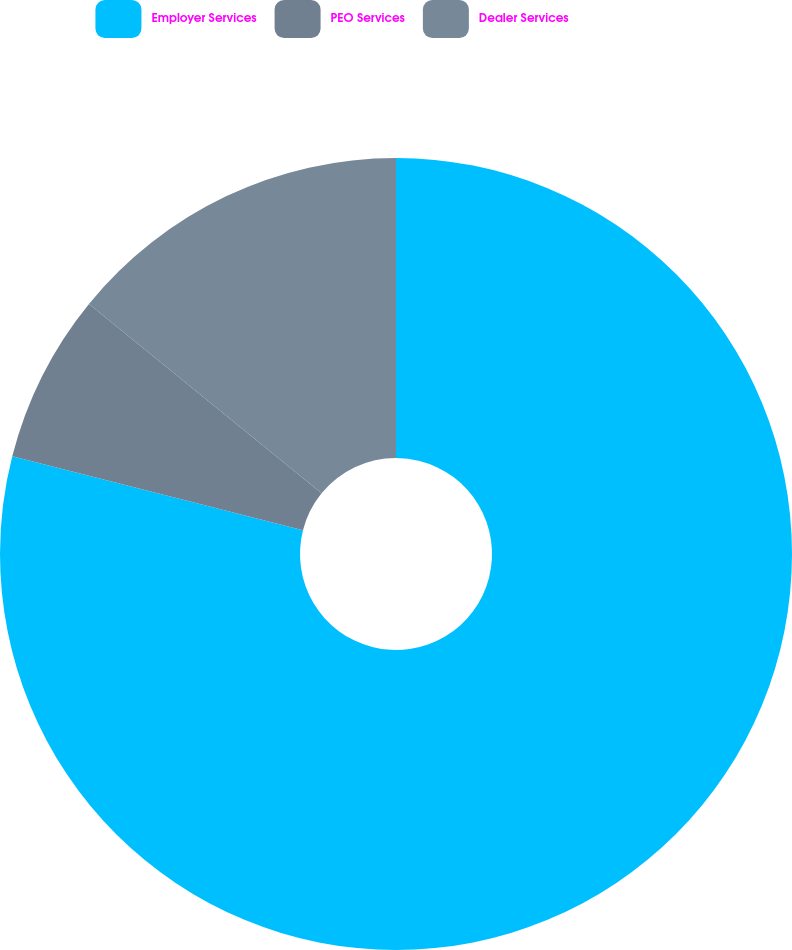Convert chart. <chart><loc_0><loc_0><loc_500><loc_500><pie_chart><fcel>Employer Services<fcel>PEO Services<fcel>Dealer Services<nl><fcel>78.97%<fcel>6.91%<fcel>14.12%<nl></chart> 